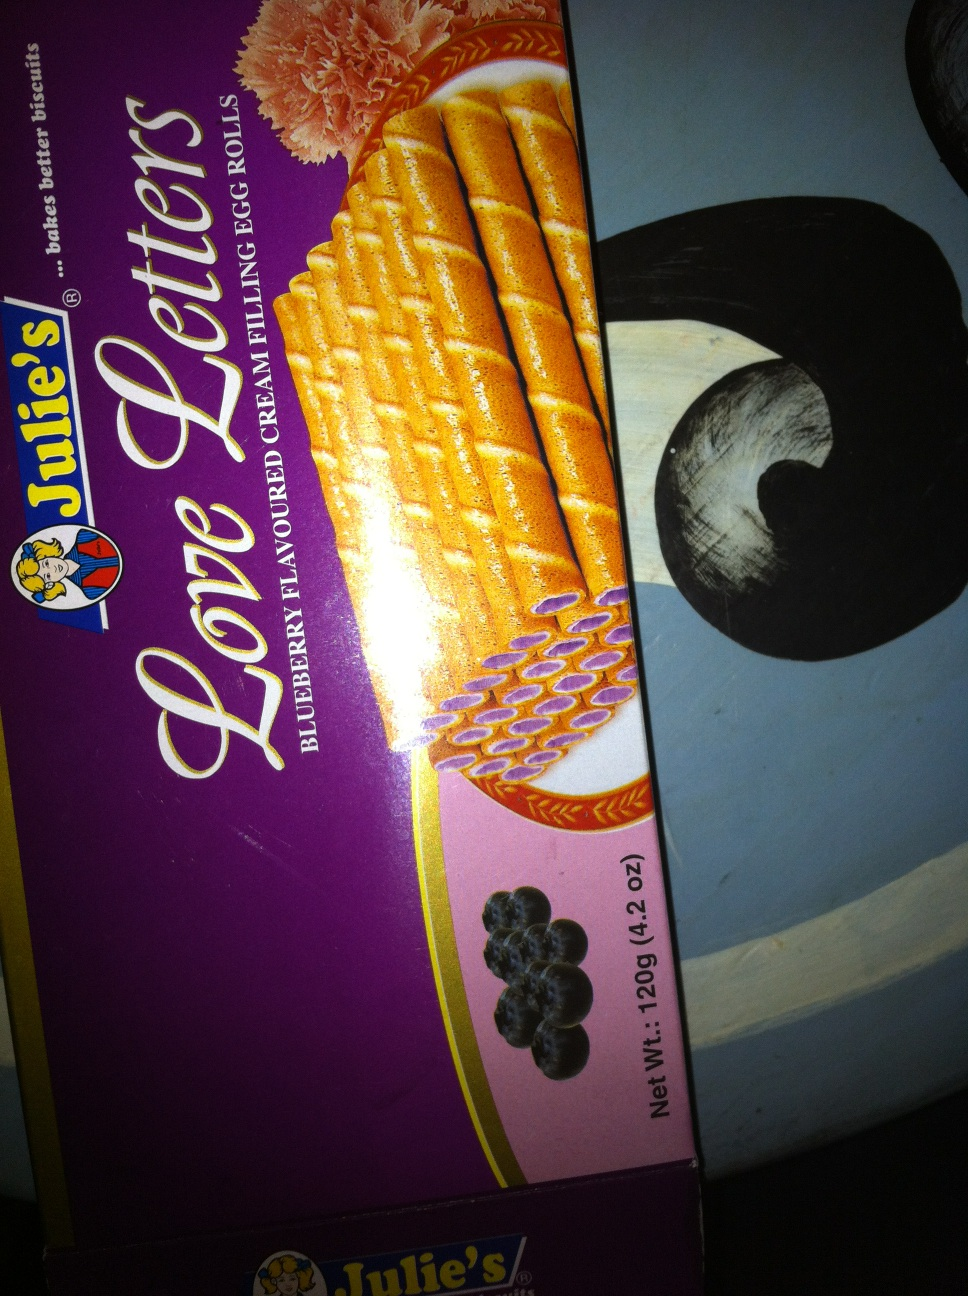Are there other flavors available for the Love Letters product? Yes, apart from the blueberry cream flavor shown in the box, Love Letters are available in several other flavors like chocolate, strawberry, and vanilla. Each flavor has a distinctive cream filling wrapped in a crispy egg roll. 